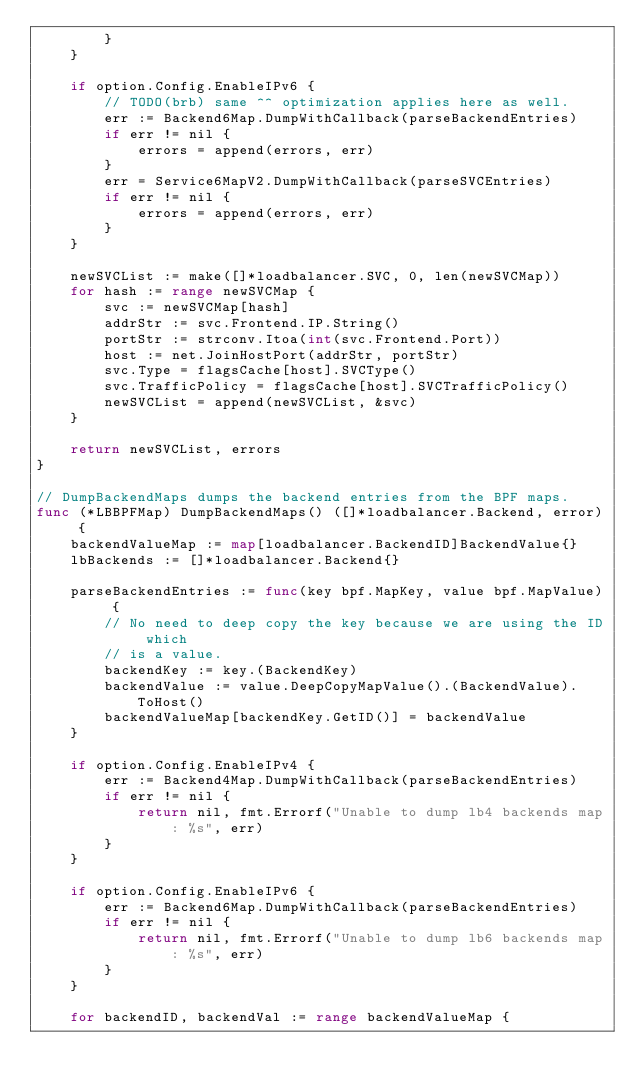Convert code to text. <code><loc_0><loc_0><loc_500><loc_500><_Go_>		}
	}

	if option.Config.EnableIPv6 {
		// TODO(brb) same ^^ optimization applies here as well.
		err := Backend6Map.DumpWithCallback(parseBackendEntries)
		if err != nil {
			errors = append(errors, err)
		}
		err = Service6MapV2.DumpWithCallback(parseSVCEntries)
		if err != nil {
			errors = append(errors, err)
		}
	}

	newSVCList := make([]*loadbalancer.SVC, 0, len(newSVCMap))
	for hash := range newSVCMap {
		svc := newSVCMap[hash]
		addrStr := svc.Frontend.IP.String()
		portStr := strconv.Itoa(int(svc.Frontend.Port))
		host := net.JoinHostPort(addrStr, portStr)
		svc.Type = flagsCache[host].SVCType()
		svc.TrafficPolicy = flagsCache[host].SVCTrafficPolicy()
		newSVCList = append(newSVCList, &svc)
	}

	return newSVCList, errors
}

// DumpBackendMaps dumps the backend entries from the BPF maps.
func (*LBBPFMap) DumpBackendMaps() ([]*loadbalancer.Backend, error) {
	backendValueMap := map[loadbalancer.BackendID]BackendValue{}
	lbBackends := []*loadbalancer.Backend{}

	parseBackendEntries := func(key bpf.MapKey, value bpf.MapValue) {
		// No need to deep copy the key because we are using the ID which
		// is a value.
		backendKey := key.(BackendKey)
		backendValue := value.DeepCopyMapValue().(BackendValue).ToHost()
		backendValueMap[backendKey.GetID()] = backendValue
	}

	if option.Config.EnableIPv4 {
		err := Backend4Map.DumpWithCallback(parseBackendEntries)
		if err != nil {
			return nil, fmt.Errorf("Unable to dump lb4 backends map: %s", err)
		}
	}

	if option.Config.EnableIPv6 {
		err := Backend6Map.DumpWithCallback(parseBackendEntries)
		if err != nil {
			return nil, fmt.Errorf("Unable to dump lb6 backends map: %s", err)
		}
	}

	for backendID, backendVal := range backendValueMap {</code> 